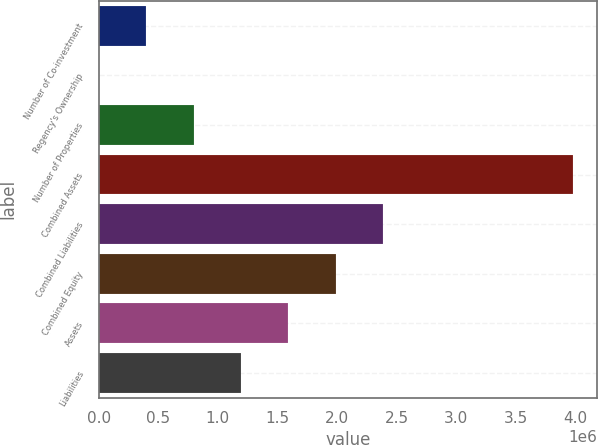Convert chart to OTSL. <chart><loc_0><loc_0><loc_500><loc_500><bar_chart><fcel>Number of Co-investment<fcel>Regency's Ownership<fcel>Number of Properties<fcel>Combined Assets<fcel>Combined Liabilities<fcel>Combined Equity<fcel>Assets<fcel>Liabilities<nl><fcel>398327<fcel>16.36<fcel>796637<fcel>3.98312e+06<fcel>2.38988e+06<fcel>1.99157e+06<fcel>1.59326e+06<fcel>1.19495e+06<nl></chart> 